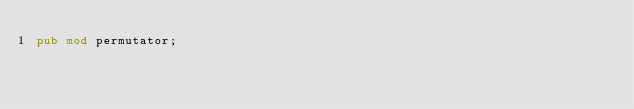<code> <loc_0><loc_0><loc_500><loc_500><_Rust_>pub mod permutator;
</code> 